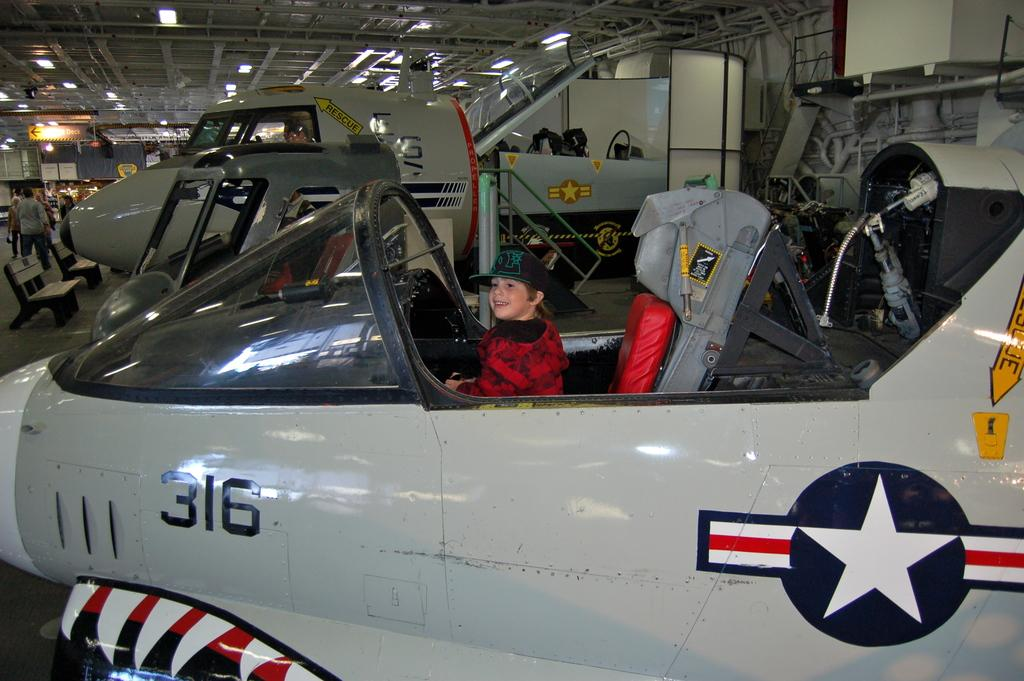<image>
Share a concise interpretation of the image provided. A young boy is sitting in the cock pit of a fighter jet with the number 316 on it. 